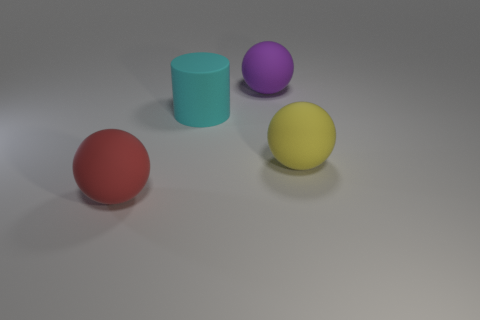The yellow thing is what shape?
Your response must be concise. Sphere. How many red matte objects have the same size as the cyan cylinder?
Offer a terse response. 1. Is the shape of the big red rubber object the same as the big yellow thing?
Offer a terse response. Yes. What is the color of the ball that is to the right of the matte ball behind the yellow thing?
Ensure brevity in your answer.  Yellow. Is there anything else that has the same color as the cylinder?
Ensure brevity in your answer.  No. The large cyan thing that is the same material as the purple sphere is what shape?
Give a very brief answer. Cylinder. There is a big purple matte thing; does it have the same shape as the large cyan thing on the left side of the yellow matte thing?
Your answer should be compact. No. What material is the large ball left of the sphere behind the yellow sphere?
Ensure brevity in your answer.  Rubber. Is the number of large red rubber spheres that are behind the large yellow rubber ball the same as the number of purple spheres?
Give a very brief answer. No. What number of rubber objects are left of the yellow rubber object and to the right of the cylinder?
Provide a short and direct response. 1. 